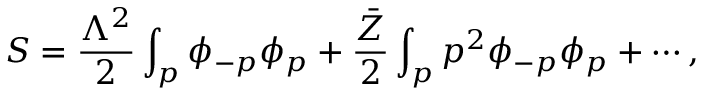<formula> <loc_0><loc_0><loc_500><loc_500>S = \frac { \Lambda ^ { 2 } } { 2 } \int _ { p } \phi _ { - p } \phi _ { p } + \frac { \bar { Z } } { 2 } \int _ { p } p ^ { 2 } \phi _ { - p } \phi _ { p } + \cdots ,</formula> 